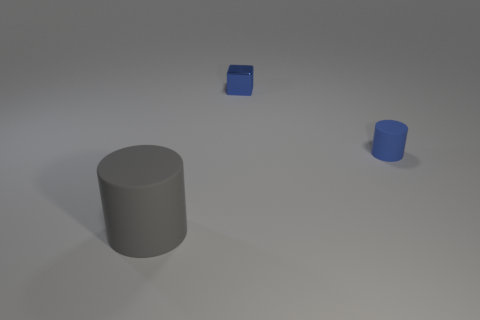The small object behind the rubber thing behind the gray matte cylinder is what shape?
Keep it short and to the point. Cube. There is a tiny blue thing that is the same material as the big cylinder; what is its shape?
Keep it short and to the point. Cylinder. Do the cylinder that is to the left of the tiny metal block and the block to the right of the large matte cylinder have the same size?
Offer a terse response. No. The blue object on the right side of the small blue block has what shape?
Offer a terse response. Cylinder. What is the color of the tiny rubber object?
Your response must be concise. Blue. There is a blue shiny object; does it have the same size as the matte object that is behind the gray rubber cylinder?
Keep it short and to the point. Yes. What number of matte things are gray things or tiny cylinders?
Provide a short and direct response. 2. Are there any other things that are the same material as the block?
Keep it short and to the point. No. Do the big cylinder and the rubber object behind the large thing have the same color?
Ensure brevity in your answer.  No. There is a small shiny thing; what shape is it?
Ensure brevity in your answer.  Cube. 